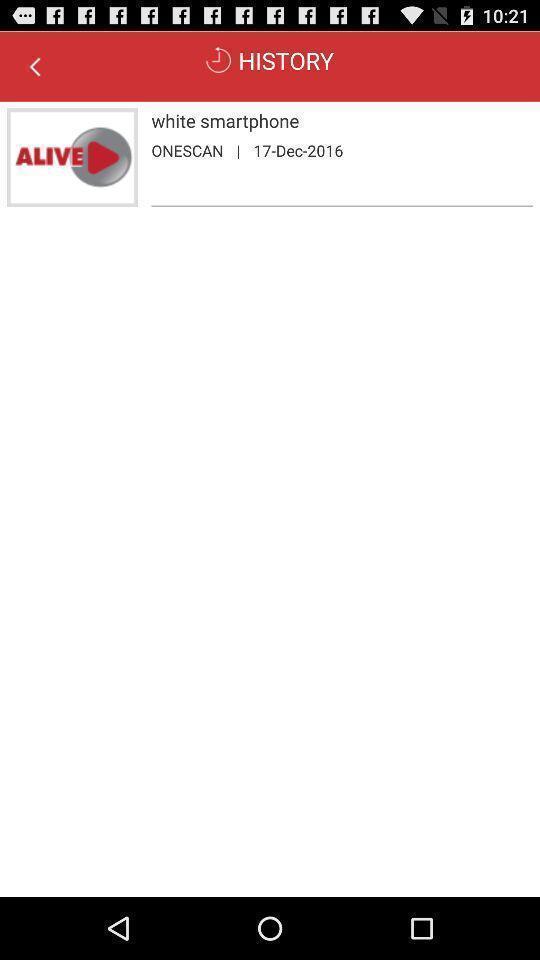Describe this image in words. Page showing the listings in history tab. 